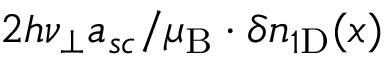Convert formula to latex. <formula><loc_0><loc_0><loc_500><loc_500>2 h \nu _ { \perp } a _ { s c } / \mu _ { B } \cdot \delta n _ { 1 D } ( x )</formula> 